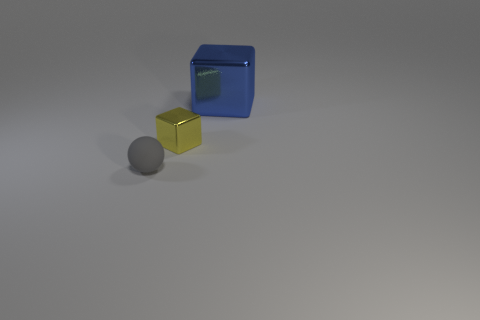Are any tiny cyan spheres visible?
Provide a succinct answer. No. What size is the other thing that is the same material as the blue thing?
Ensure brevity in your answer.  Small. Is the small gray thing made of the same material as the big cube?
Keep it short and to the point. No. What number of other objects are the same material as the tiny gray thing?
Your answer should be compact. 0. What number of things are both on the left side of the small block and behind the rubber ball?
Make the answer very short. 0. What is the color of the large cube?
Your response must be concise. Blue. There is a large object that is the same shape as the tiny shiny object; what material is it?
Keep it short and to the point. Metal. Is there anything else that is the same material as the big blue cube?
Offer a very short reply. Yes. Is the color of the large shiny block the same as the small matte thing?
Keep it short and to the point. No. What shape is the object that is in front of the small object behind the gray sphere?
Ensure brevity in your answer.  Sphere. 